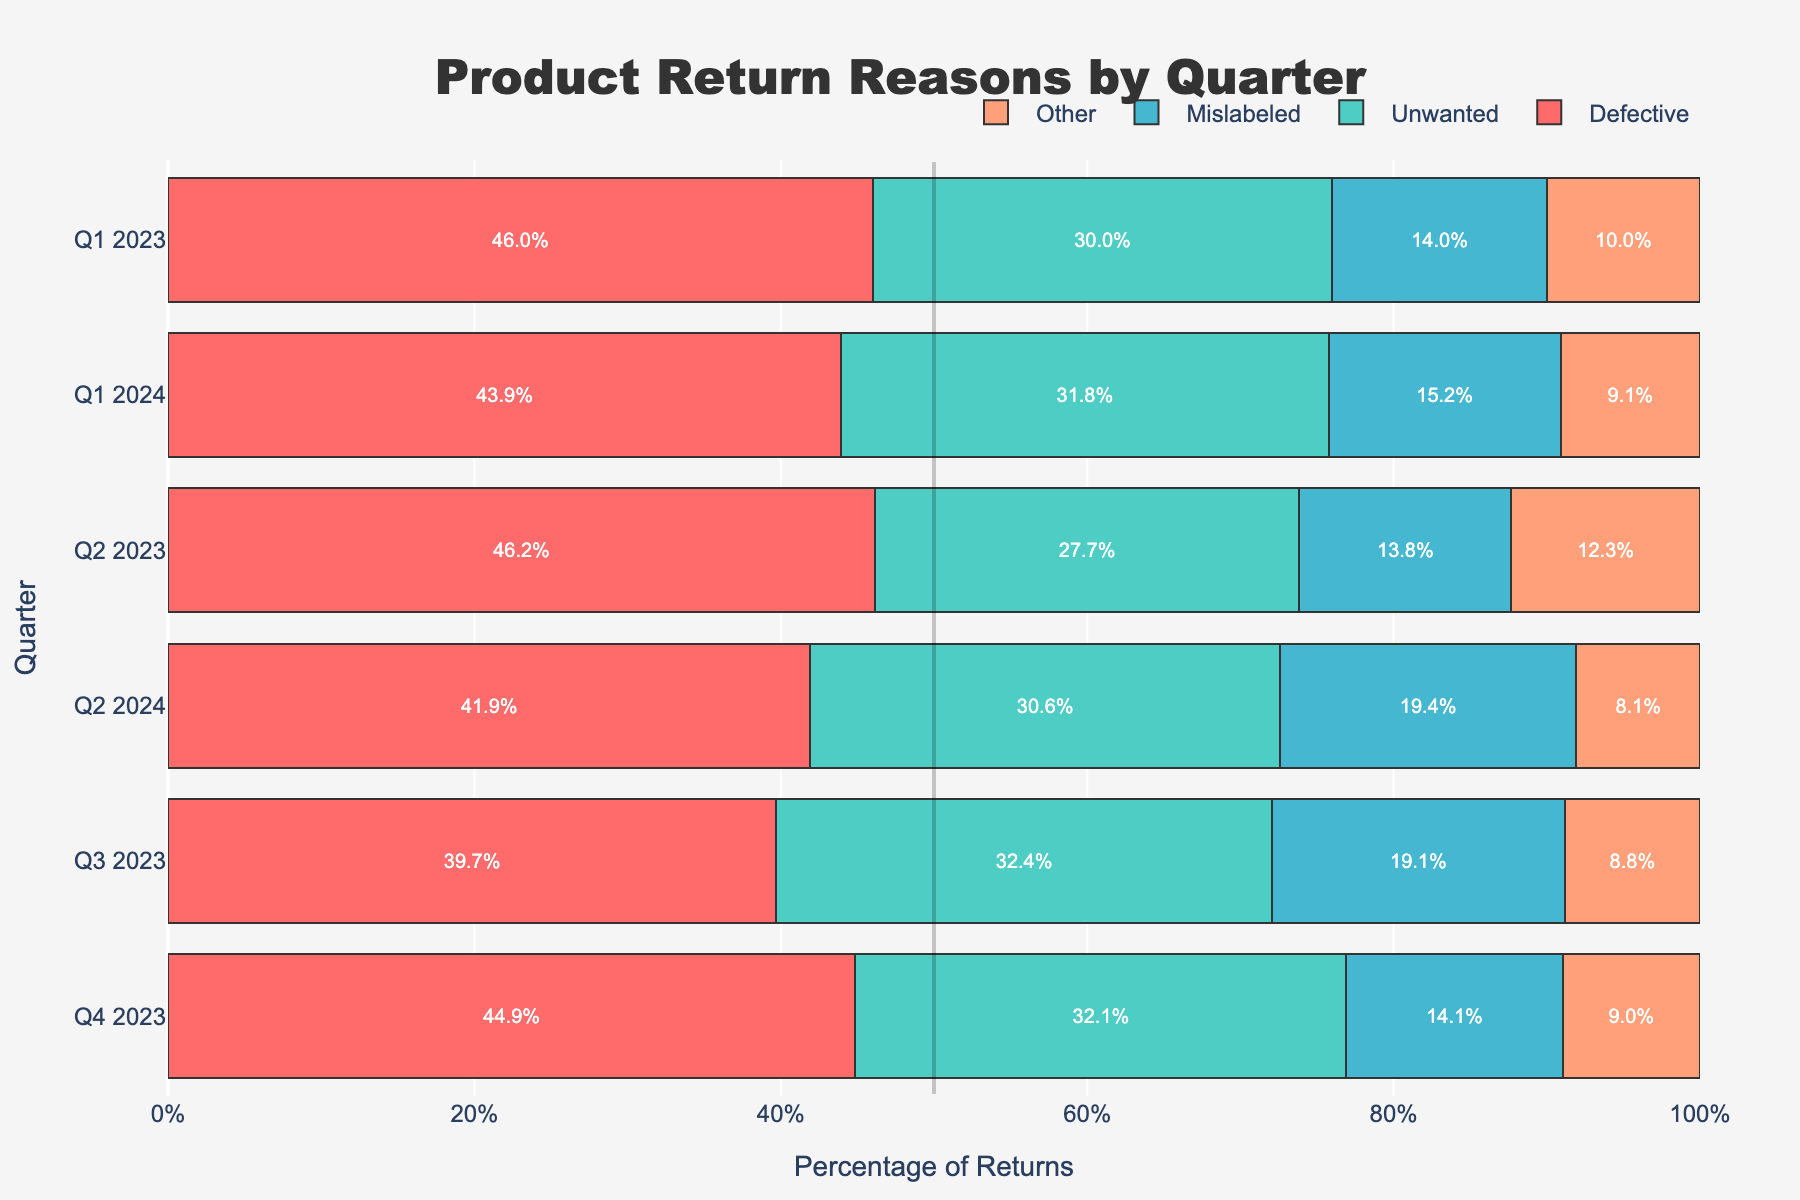What is the most frequent reason for product returns in Q1 2023? In Q1 2023, the bar representing the "Defective" category has the largest percentage compared to "Unwanted," "Mislabeled," and "Other."
Answer: Defective Which quarter had the highest percentage of returns due to the "Other" category? By comparing the lengths of the "Other" category bars across all quarters, Q2 2023 had the longest bar, indicating the highest percentage.
Answer: Q2 2023 How does the percentage of "Unwanted" returns change from Q1 2023 to Q4 2023? The percentage of "Unwanted" returns in Q1 2023 is lower compared to Q4 2023. Specifically, the bar for "Unwanted" grows longer as the quarters progress from Q1 2023 to Q4 2023.
Answer: Increases What is the average percentage of returns for the "Mislabeled" category across all quarters? Calculate the percentage for "Mislabeled" in each quarter and then average them. Sum: (7/50*100 + 9/65*100 + 13/68*100 + 11/78*100 + 10/66*100 + 12/62*100)/6.
Answer: ~11% Which category saw the most significant change in percentage terms between Q4 2023 and Q1 2024? By comparing the differences in bar lengths for each category between Q4 2023 and Q1 2024, "Unwanted" shows a noticeable decrease.
Answer: Unwanted In which quarter did "Defective" returns exceed 50% of all returns? None of the "Defective" bars reach or exceed the halfway point (50%) mark on the horizontal scale from 0% to 100%.
Answer: None Which quarter had the smallest percentage of "Unwanted" returns, and what was the percentage? The smallest bar for "Unwanted" is in Q1 2023. The hover text or text inside the bar gives the exact percentage.
Answer: Q1 2023, approximately 23.1% What is the total count of all returns in Q2 2023? Sum all counts for Q2 2023: Defective (30) + Unwanted (18) + Mislabeled (9) + Other (8). The total is therefore 30 + 18 + 9 + 8 = 65.
Answer: 65 Did the "Defective" return category increase or decrease from Q3 2023 to Q4 2023, and by how much? The "Defective" bar grows from Q3 to Q4. The increment can be found by subtracting the Q3 count (27) from Q4 count (35), which yields 35 - 27 = 8.
Answer: Increased by 8 What percentage of the returns in Q2 2024 were "Defective"? The "Defective" category has a certain length, which provides the percentage directly, validate by calculation: (26/62)*100 ≈ 41.9%.
Answer: 41.9% 